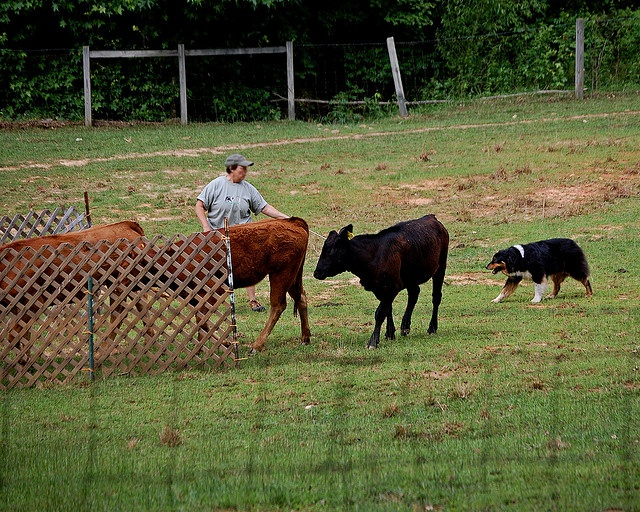Describe the objects in this image and their specific colors. I can see cow in black, maroon, and gray tones, cow in black, gray, and maroon tones, cow in black, maroon, gray, and darkgreen tones, dog in black, olive, and maroon tones, and people in black, darkgray, gray, and lavender tones in this image. 